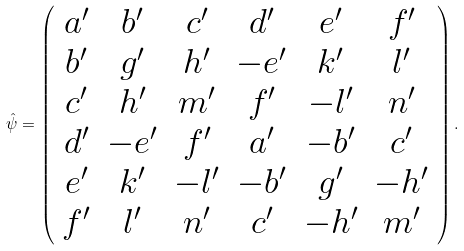<formula> <loc_0><loc_0><loc_500><loc_500>\hat { \psi } = \left ( \begin{array} { c c c c c c } a ^ { \prime } & b ^ { \prime } & c ^ { \prime } & d ^ { \prime } & e ^ { \prime } & f ^ { \prime } \\ b ^ { \prime } & g ^ { \prime } & h ^ { \prime } & - e ^ { \prime } & k ^ { \prime } & l ^ { \prime } \\ c ^ { \prime } & h ^ { \prime } & m ^ { \prime } & f ^ { \prime } & - l ^ { \prime } & n ^ { \prime } \\ d ^ { \prime } & - e ^ { \prime } & f ^ { \prime } & a ^ { \prime } & - b ^ { \prime } & c ^ { \prime } \\ e ^ { \prime } & k ^ { \prime } & - l ^ { \prime } & - b ^ { \prime } & g ^ { \prime } & - h ^ { \prime } \\ f ^ { \prime } & l ^ { \prime } & n ^ { \prime } & c ^ { \prime } & - h ^ { \prime } & m ^ { \prime } \\ \end{array} \right ) .</formula> 